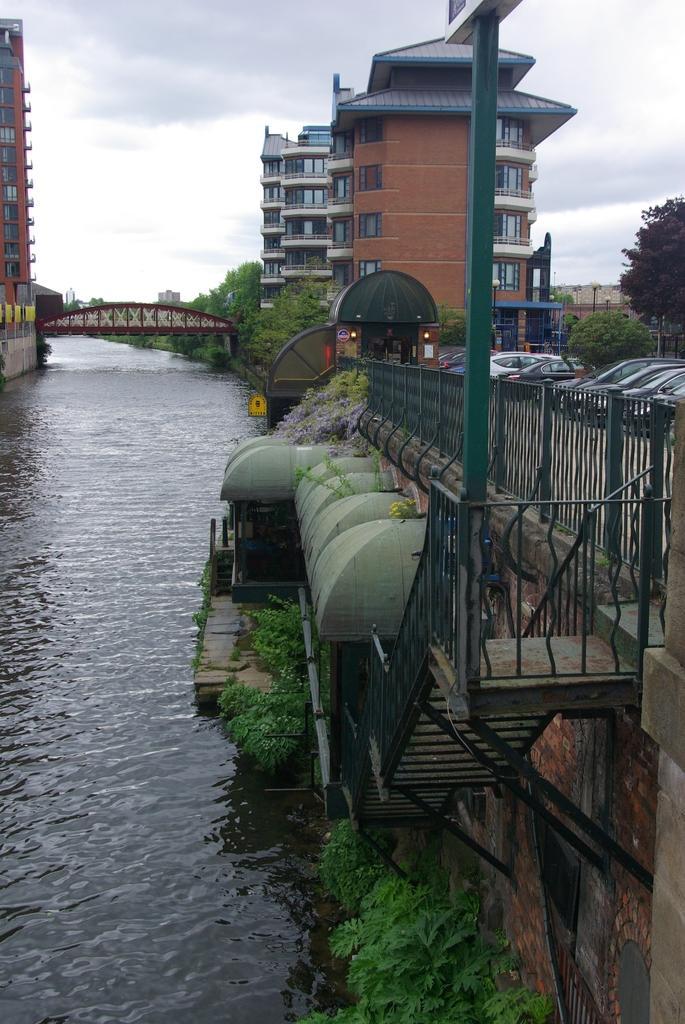Can you describe this image briefly? This picture consists of the lake and there is a bridge , fence , cars building , pole ,vehicles, staircase visible ob the right side , at the top there is the sky visible. 